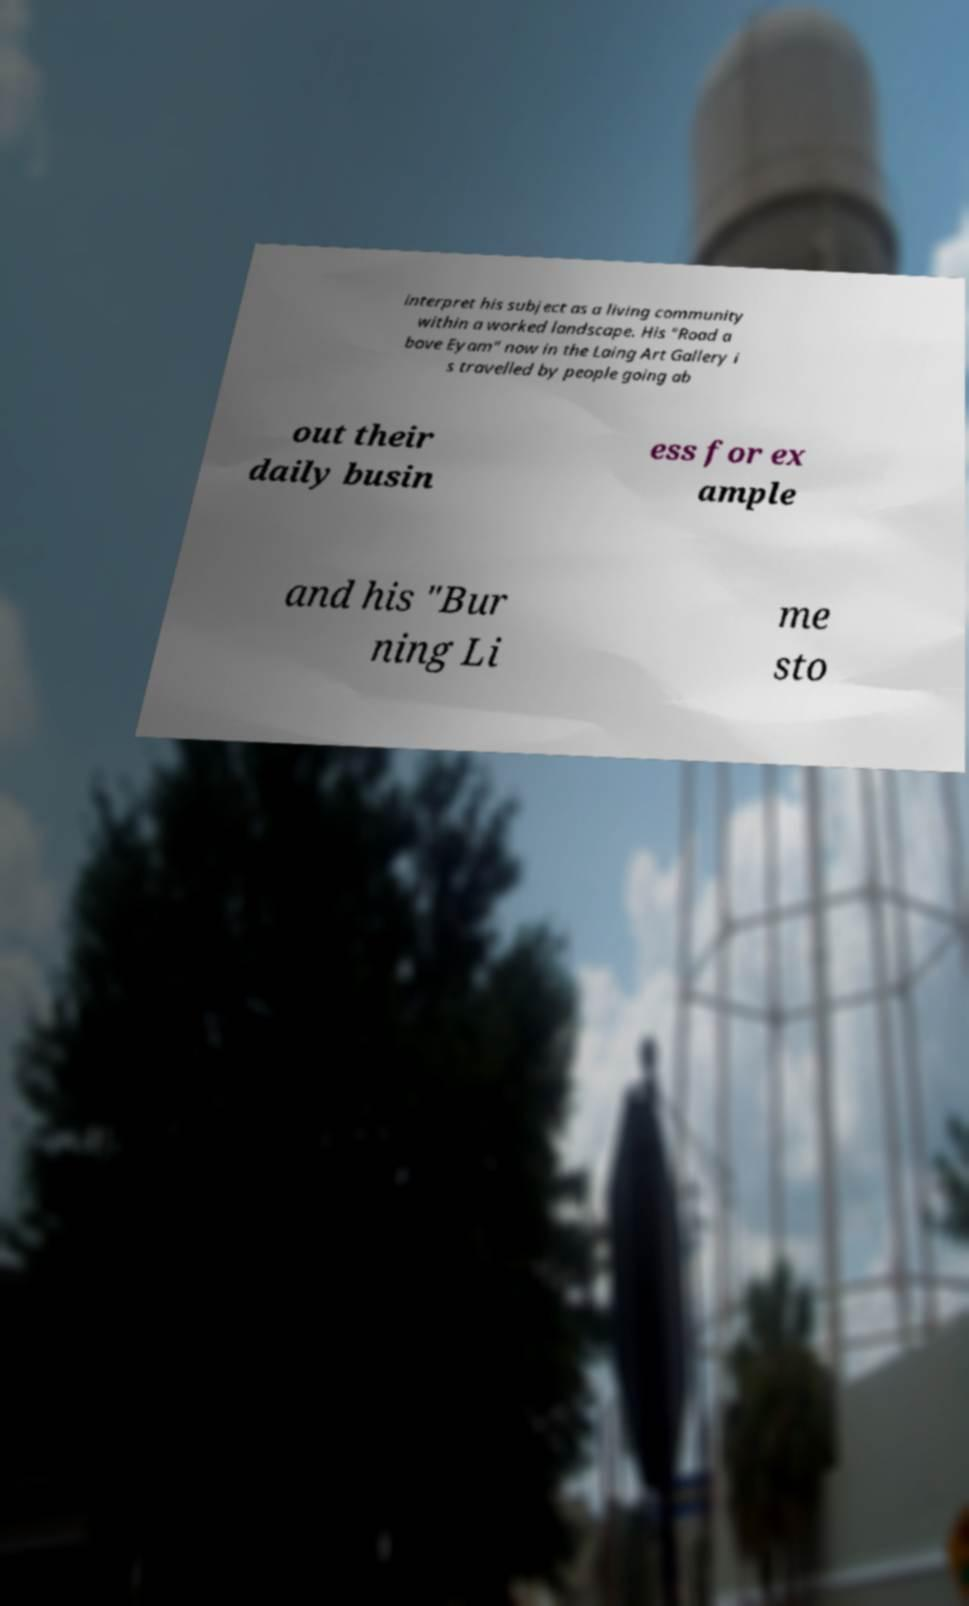Could you extract and type out the text from this image? interpret his subject as a living community within a worked landscape. His "Road a bove Eyam" now in the Laing Art Gallery i s travelled by people going ab out their daily busin ess for ex ample and his "Bur ning Li me sto 